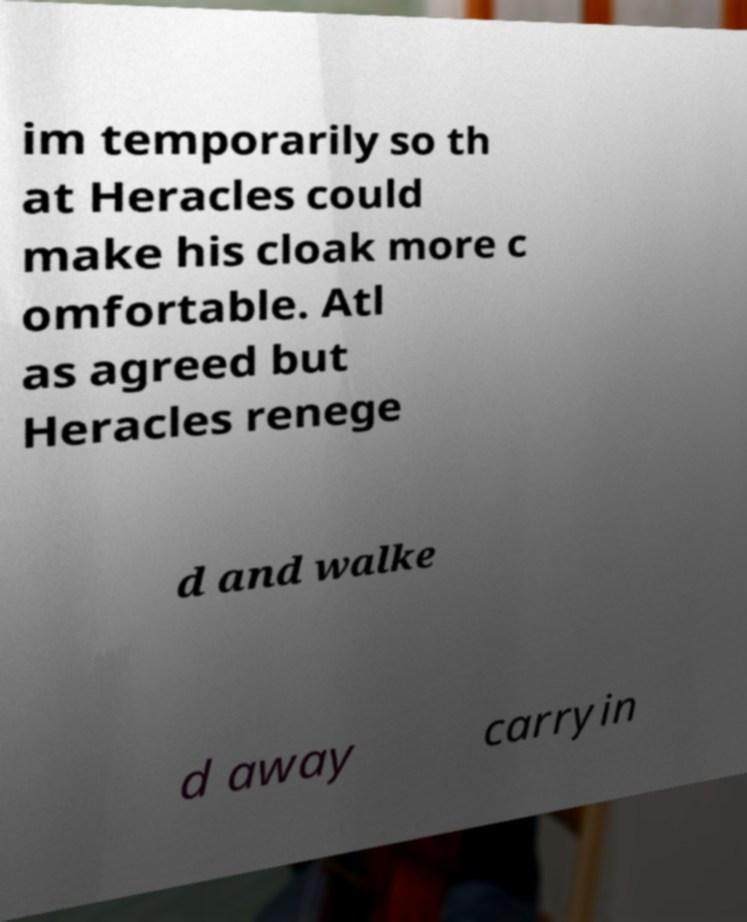There's text embedded in this image that I need extracted. Can you transcribe it verbatim? im temporarily so th at Heracles could make his cloak more c omfortable. Atl as agreed but Heracles renege d and walke d away carryin 